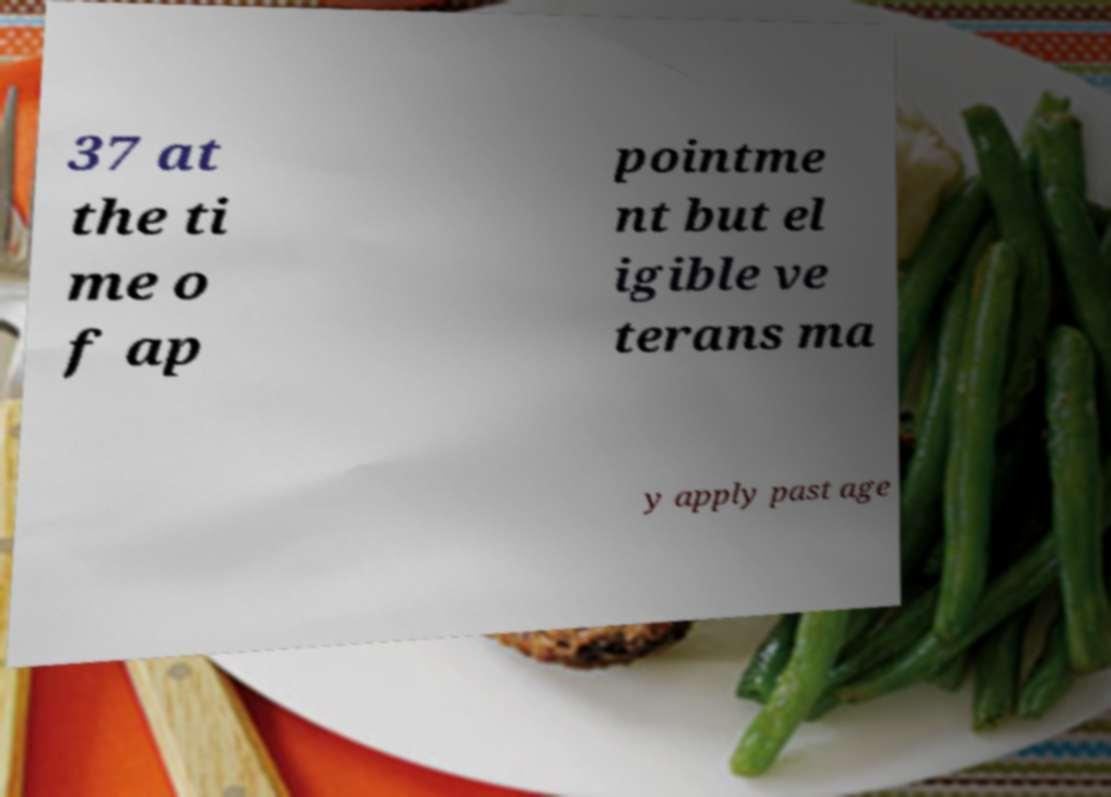For documentation purposes, I need the text within this image transcribed. Could you provide that? 37 at the ti me o f ap pointme nt but el igible ve terans ma y apply past age 